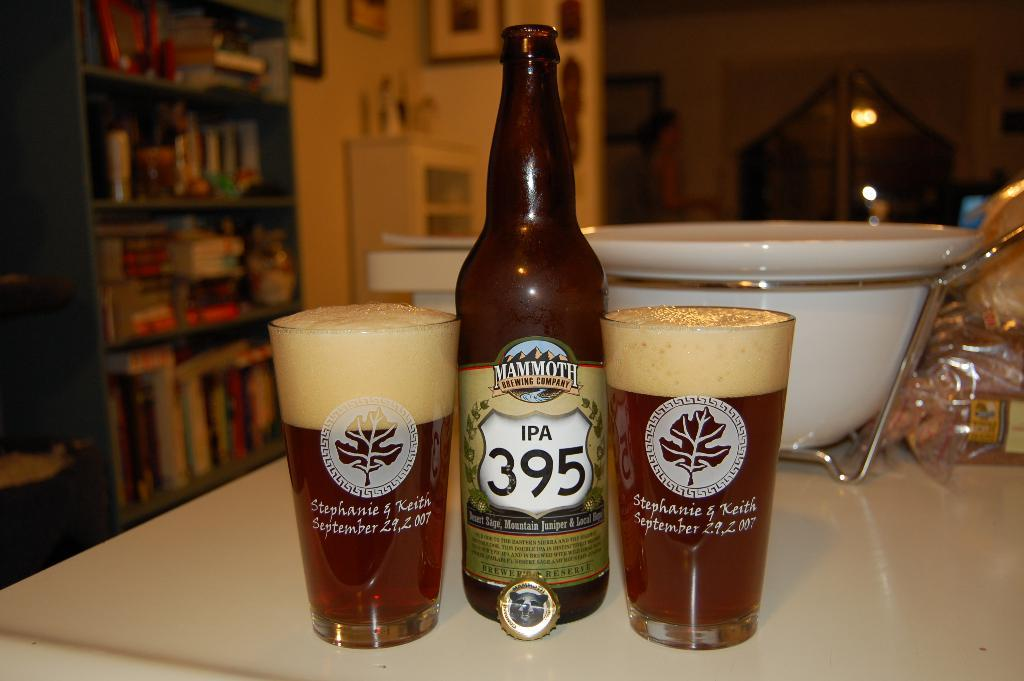<image>
Relay a brief, clear account of the picture shown. Two glasses with Mammoth Brewing company IPA 395. 